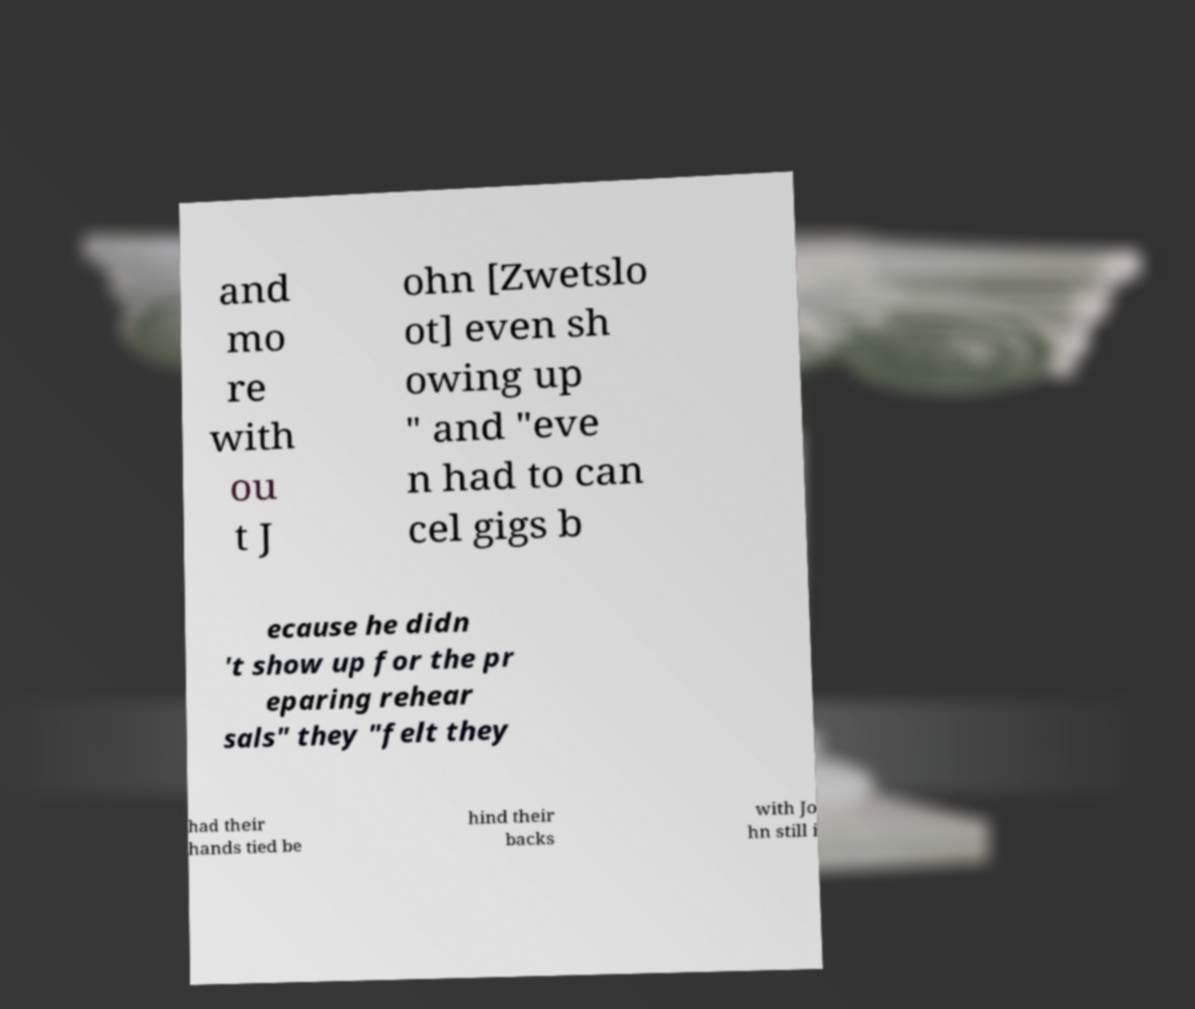I need the written content from this picture converted into text. Can you do that? and mo re with ou t J ohn [Zwetslo ot] even sh owing up " and "eve n had to can cel gigs b ecause he didn 't show up for the pr eparing rehear sals" they "felt they had their hands tied be hind their backs with Jo hn still i 